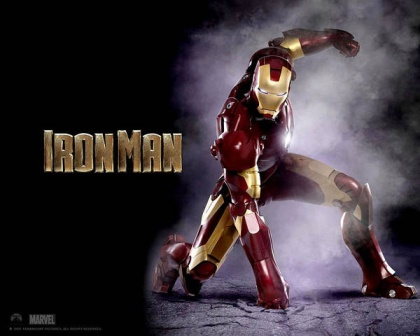What kind of adventures might Iron Man embark on in deep space? In deep space, Iron Man could embark on a multitude of exhilarating adventures. He might explore uncharted galaxies, encountering alien civilizations and forming alliances with extraterrestrial heroes. He could engage in cosmic battles against powerful foes threatening the universe or hunt for rare cosmic materials to upgrade his suit. Iron Man's ventures might include investigating anomalies in spacetime, safeguarding interstellar trade routes from space pirates, and even cooperating with cosmic entities like the Guardians of the Galaxy to thwart large-scale cosmic threats. Each adventure would push the limits of his technology and his ingenuity, offering endless opportunities for heroic feats and cosmic discoveries. 